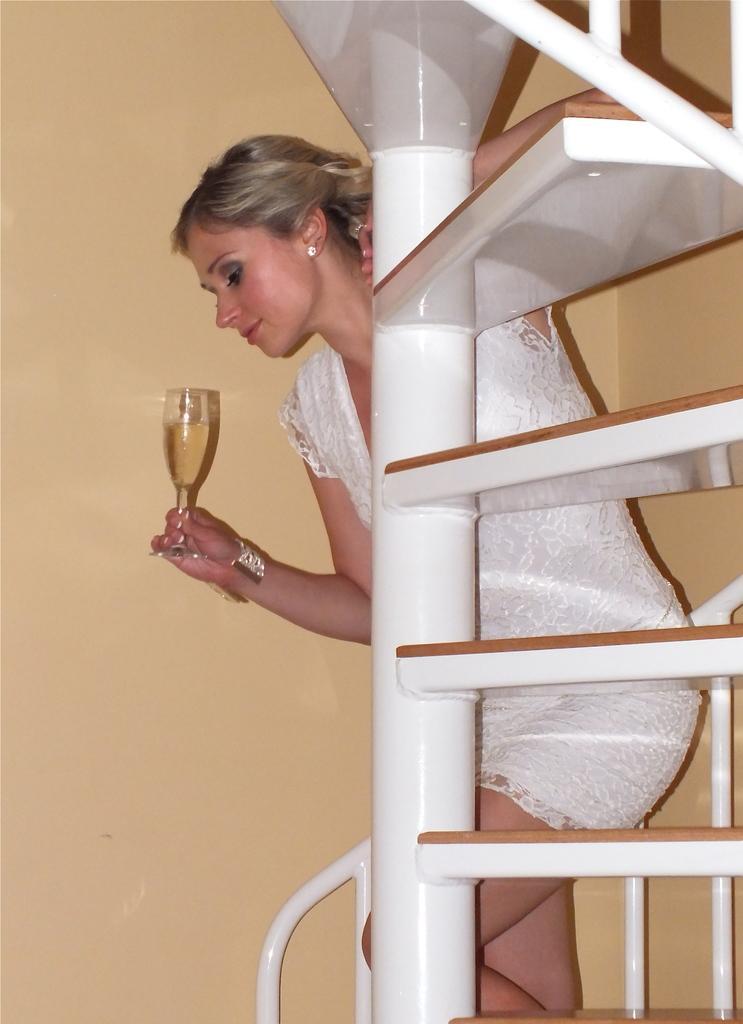Could you give a brief overview of what you see in this image? In this image we can see a person walking on the stairs and holding a glass with a drink. Beside her we can see the wall. 